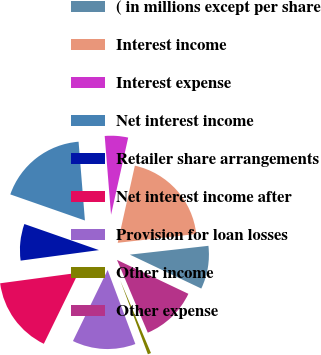<chart> <loc_0><loc_0><loc_500><loc_500><pie_chart><fcel>( in millions except per share<fcel>Interest income<fcel>Interest expense<fcel>Net interest income<fcel>Retailer share arrangements<fcel>Net interest income after<fcel>Provision for loan losses<fcel>Other income<fcel>Other expense<nl><fcel>8.84%<fcel>19.74%<fcel>4.76%<fcel>18.37%<fcel>7.48%<fcel>15.65%<fcel>12.93%<fcel>0.67%<fcel>11.57%<nl></chart> 